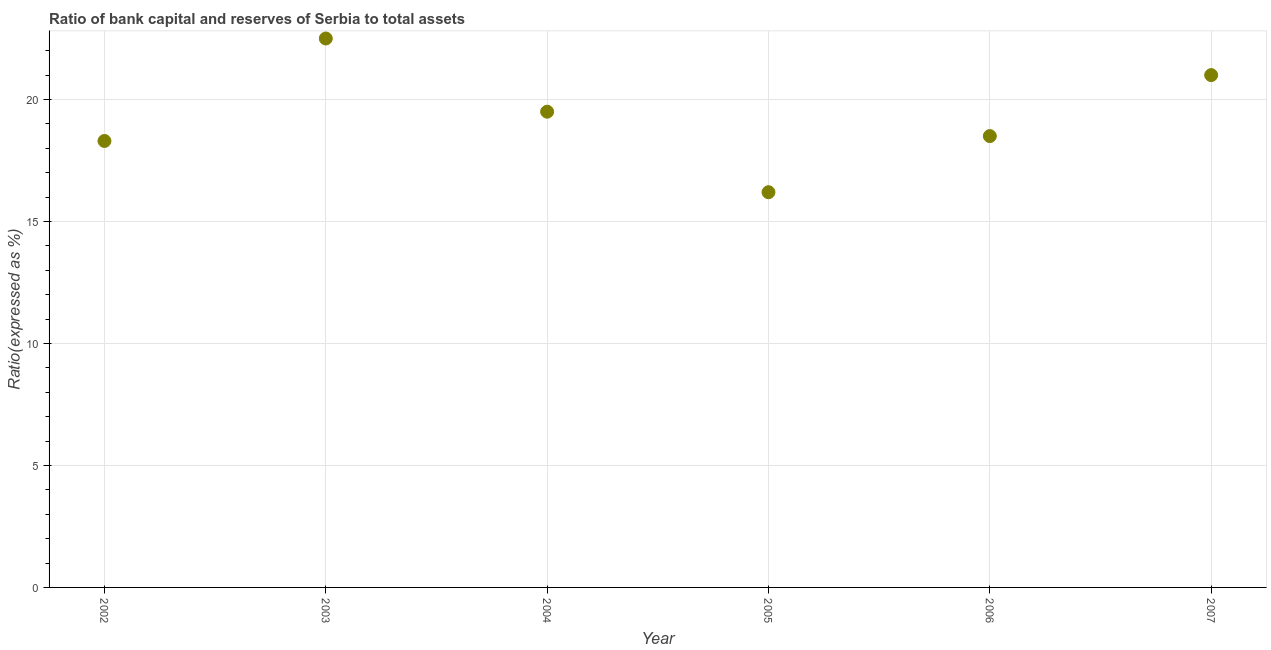Across all years, what is the maximum bank capital to assets ratio?
Provide a short and direct response. 22.5. In which year was the bank capital to assets ratio maximum?
Keep it short and to the point. 2003. In which year was the bank capital to assets ratio minimum?
Make the answer very short. 2005. What is the sum of the bank capital to assets ratio?
Keep it short and to the point. 116. What is the difference between the bank capital to assets ratio in 2002 and 2003?
Offer a very short reply. -4.2. What is the average bank capital to assets ratio per year?
Your answer should be very brief. 19.33. What is the median bank capital to assets ratio?
Give a very brief answer. 19. In how many years, is the bank capital to assets ratio greater than 18 %?
Give a very brief answer. 5. What is the ratio of the bank capital to assets ratio in 2004 to that in 2006?
Your answer should be compact. 1.05. Is the bank capital to assets ratio in 2002 less than that in 2006?
Provide a succinct answer. Yes. Is the difference between the bank capital to assets ratio in 2002 and 2005 greater than the difference between any two years?
Provide a succinct answer. No. What is the difference between the highest and the second highest bank capital to assets ratio?
Your answer should be compact. 1.5. Is the sum of the bank capital to assets ratio in 2003 and 2005 greater than the maximum bank capital to assets ratio across all years?
Provide a succinct answer. Yes. What is the difference between the highest and the lowest bank capital to assets ratio?
Provide a short and direct response. 6.3. In how many years, is the bank capital to assets ratio greater than the average bank capital to assets ratio taken over all years?
Keep it short and to the point. 3. Does the bank capital to assets ratio monotonically increase over the years?
Ensure brevity in your answer.  No. How many dotlines are there?
Provide a succinct answer. 1. Are the values on the major ticks of Y-axis written in scientific E-notation?
Ensure brevity in your answer.  No. What is the title of the graph?
Provide a short and direct response. Ratio of bank capital and reserves of Serbia to total assets. What is the label or title of the X-axis?
Your answer should be compact. Year. What is the label or title of the Y-axis?
Your answer should be very brief. Ratio(expressed as %). What is the Ratio(expressed as %) in 2002?
Your response must be concise. 18.3. What is the Ratio(expressed as %) in 2006?
Offer a terse response. 18.5. What is the Ratio(expressed as %) in 2007?
Keep it short and to the point. 21. What is the difference between the Ratio(expressed as %) in 2002 and 2003?
Provide a short and direct response. -4.2. What is the difference between the Ratio(expressed as %) in 2002 and 2006?
Provide a short and direct response. -0.2. What is the difference between the Ratio(expressed as %) in 2003 and 2004?
Give a very brief answer. 3. What is the difference between the Ratio(expressed as %) in 2003 and 2005?
Offer a terse response. 6.3. What is the difference between the Ratio(expressed as %) in 2005 and 2006?
Offer a very short reply. -2.3. What is the difference between the Ratio(expressed as %) in 2005 and 2007?
Give a very brief answer. -4.8. What is the ratio of the Ratio(expressed as %) in 2002 to that in 2003?
Your answer should be compact. 0.81. What is the ratio of the Ratio(expressed as %) in 2002 to that in 2004?
Ensure brevity in your answer.  0.94. What is the ratio of the Ratio(expressed as %) in 2002 to that in 2005?
Make the answer very short. 1.13. What is the ratio of the Ratio(expressed as %) in 2002 to that in 2007?
Provide a succinct answer. 0.87. What is the ratio of the Ratio(expressed as %) in 2003 to that in 2004?
Your answer should be compact. 1.15. What is the ratio of the Ratio(expressed as %) in 2003 to that in 2005?
Your answer should be very brief. 1.39. What is the ratio of the Ratio(expressed as %) in 2003 to that in 2006?
Make the answer very short. 1.22. What is the ratio of the Ratio(expressed as %) in 2003 to that in 2007?
Offer a terse response. 1.07. What is the ratio of the Ratio(expressed as %) in 2004 to that in 2005?
Your answer should be compact. 1.2. What is the ratio of the Ratio(expressed as %) in 2004 to that in 2006?
Keep it short and to the point. 1.05. What is the ratio of the Ratio(expressed as %) in 2004 to that in 2007?
Provide a short and direct response. 0.93. What is the ratio of the Ratio(expressed as %) in 2005 to that in 2006?
Your answer should be compact. 0.88. What is the ratio of the Ratio(expressed as %) in 2005 to that in 2007?
Provide a short and direct response. 0.77. What is the ratio of the Ratio(expressed as %) in 2006 to that in 2007?
Make the answer very short. 0.88. 